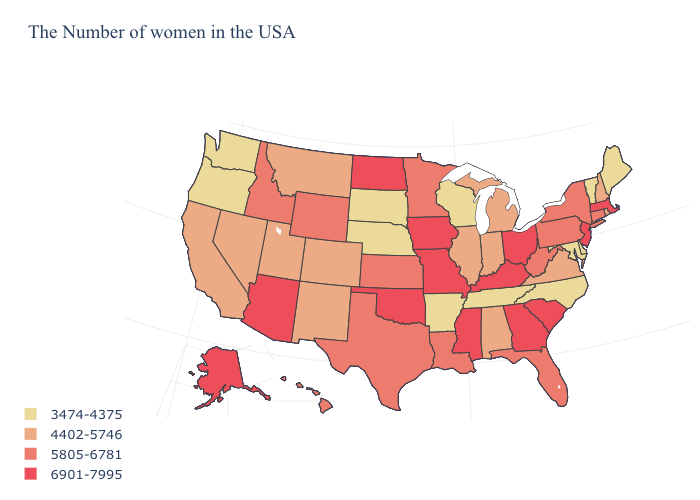Name the states that have a value in the range 4402-5746?
Concise answer only. Rhode Island, New Hampshire, Virginia, Michigan, Indiana, Alabama, Illinois, Colorado, New Mexico, Utah, Montana, Nevada, California. How many symbols are there in the legend?
Give a very brief answer. 4. Name the states that have a value in the range 3474-4375?
Quick response, please. Maine, Vermont, Delaware, Maryland, North Carolina, Tennessee, Wisconsin, Arkansas, Nebraska, South Dakota, Washington, Oregon. Name the states that have a value in the range 3474-4375?
Short answer required. Maine, Vermont, Delaware, Maryland, North Carolina, Tennessee, Wisconsin, Arkansas, Nebraska, South Dakota, Washington, Oregon. Name the states that have a value in the range 6901-7995?
Be succinct. Massachusetts, New Jersey, South Carolina, Ohio, Georgia, Kentucky, Mississippi, Missouri, Iowa, Oklahoma, North Dakota, Arizona, Alaska. Does the map have missing data?
Keep it brief. No. Does South Dakota have the lowest value in the MidWest?
Short answer required. Yes. Does Illinois have the highest value in the MidWest?
Concise answer only. No. What is the value of Florida?
Answer briefly. 5805-6781. What is the lowest value in the USA?
Quick response, please. 3474-4375. Among the states that border Louisiana , which have the lowest value?
Concise answer only. Arkansas. Does Oklahoma have a lower value than Washington?
Concise answer only. No. Does the map have missing data?
Quick response, please. No. Does Kansas have the lowest value in the MidWest?
Give a very brief answer. No. What is the value of Rhode Island?
Keep it brief. 4402-5746. 